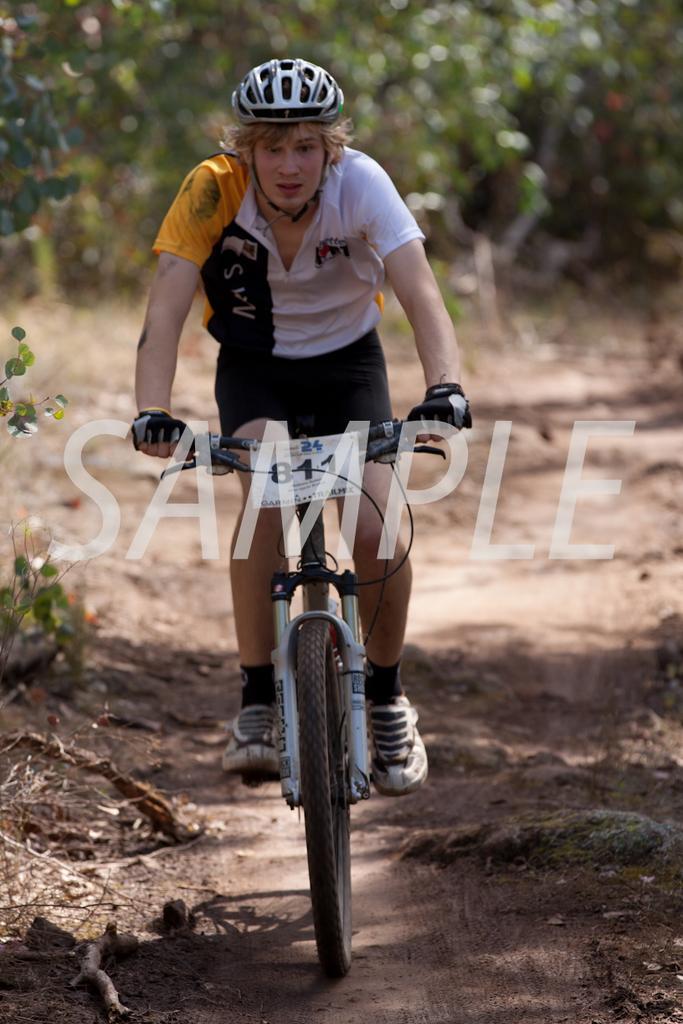Please provide a concise description of this image. In this image, in the middle, we can see a man riding on the bicycle. In the background, we can see some trees. At the bottom, we can see a land with some stones. 